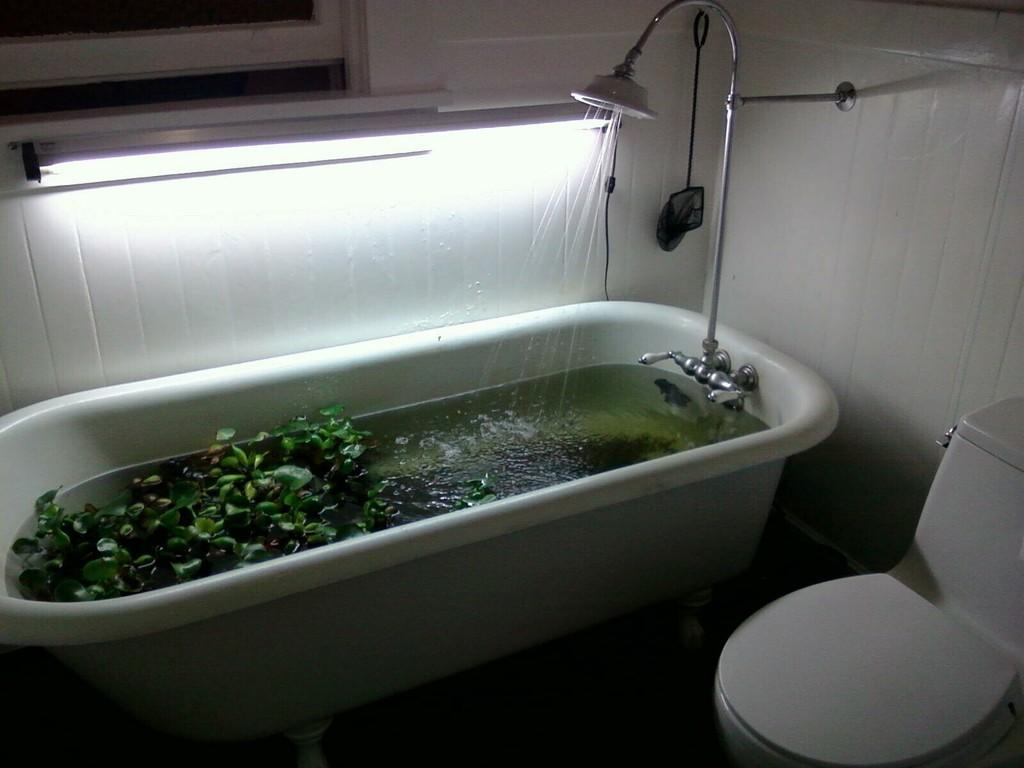What is the main object in the image? There is a bathtub in the image. What can be found inside the bathtub? There are leaves and water in the bathtub. What is the purpose of the object next to the bathtub? There is a shower in the image, which is used for washing. Can you describe the source of light in the image? There is a light in the image, which provides illumination. What type of toilet is present in the image? There is a western toilet in the image. How many hours does the lace take to dry in the image? There is no lace present in the image, so it is not possible to determine how long it would take to dry. 